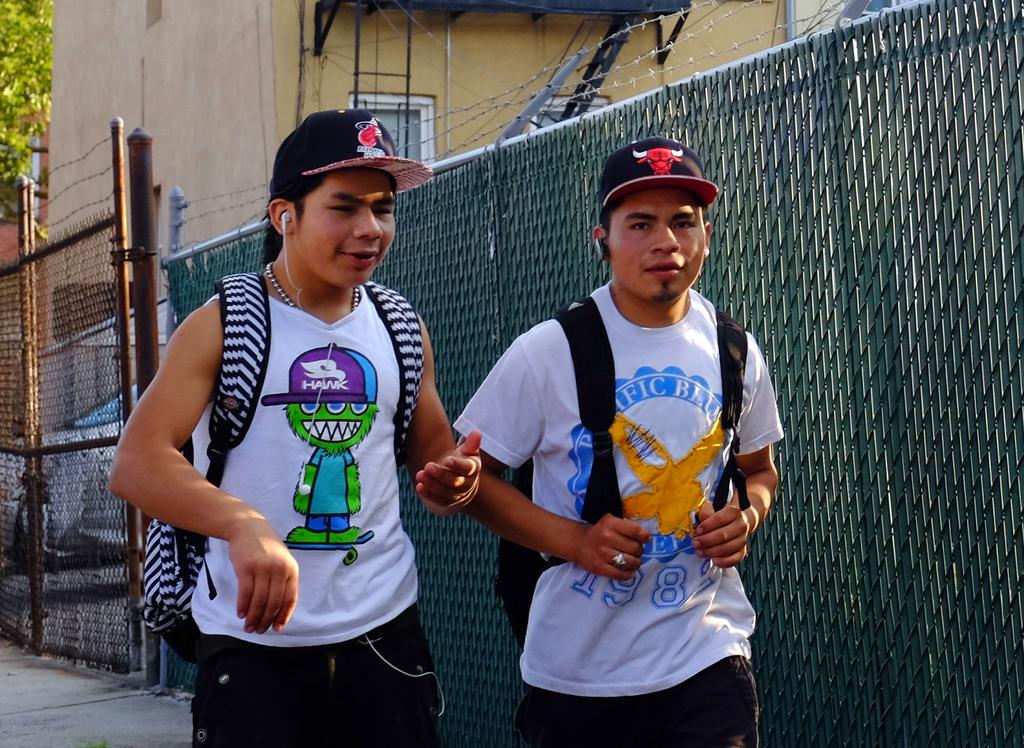<image>
Offer a succinct explanation of the picture presented. two boys walking, one with Pacific Blue on his white tee shirt 